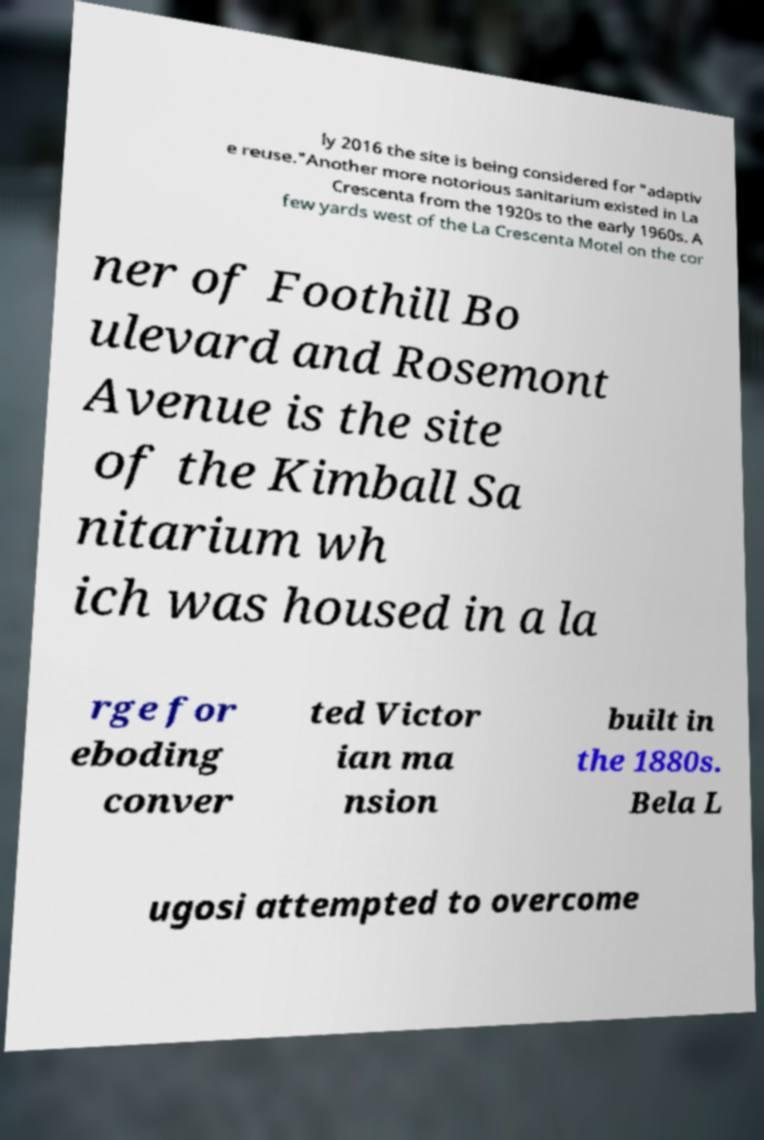Can you read and provide the text displayed in the image?This photo seems to have some interesting text. Can you extract and type it out for me? ly 2016 the site is being considered for "adaptiv e reuse."Another more notorious sanitarium existed in La Crescenta from the 1920s to the early 1960s. A few yards west of the La Crescenta Motel on the cor ner of Foothill Bo ulevard and Rosemont Avenue is the site of the Kimball Sa nitarium wh ich was housed in a la rge for eboding conver ted Victor ian ma nsion built in the 1880s. Bela L ugosi attempted to overcome 